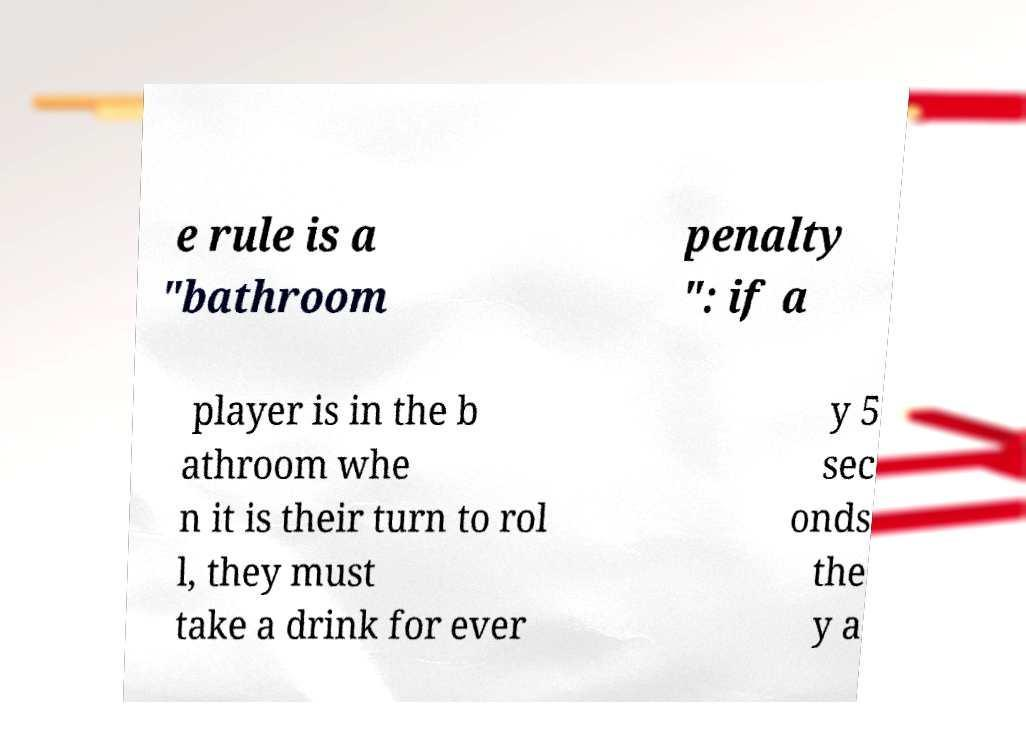What messages or text are displayed in this image? I need them in a readable, typed format. e rule is a "bathroom penalty ": if a player is in the b athroom whe n it is their turn to rol l, they must take a drink for ever y 5 sec onds the y a 